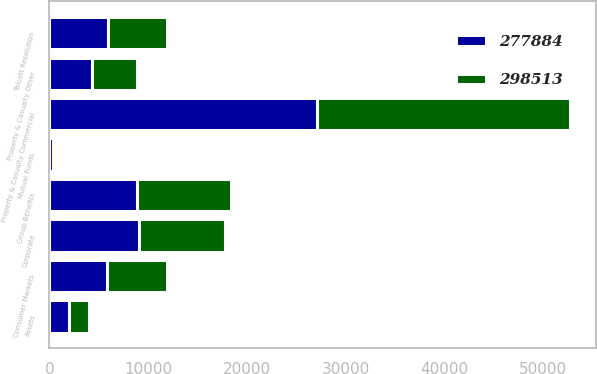Convert chart to OTSL. <chart><loc_0><loc_0><loc_500><loc_500><stacked_bar_chart><ecel><fcel>Assets<fcel>Property & Casualty Commercial<fcel>Consumer Markets<fcel>Property & Casualty Other<fcel>Group Benefits<fcel>Mutual Funds<fcel>Talcott Resolution<fcel>Corporate<nl><fcel>277884<fcel>2013<fcel>27119<fcel>5873<fcel>4331<fcel>8882<fcel>307<fcel>5948.5<fcel>9103<nl><fcel>298513<fcel>2012<fcel>25595<fcel>6024<fcel>4509<fcel>9545<fcel>325<fcel>5948.5<fcel>8679<nl></chart> 